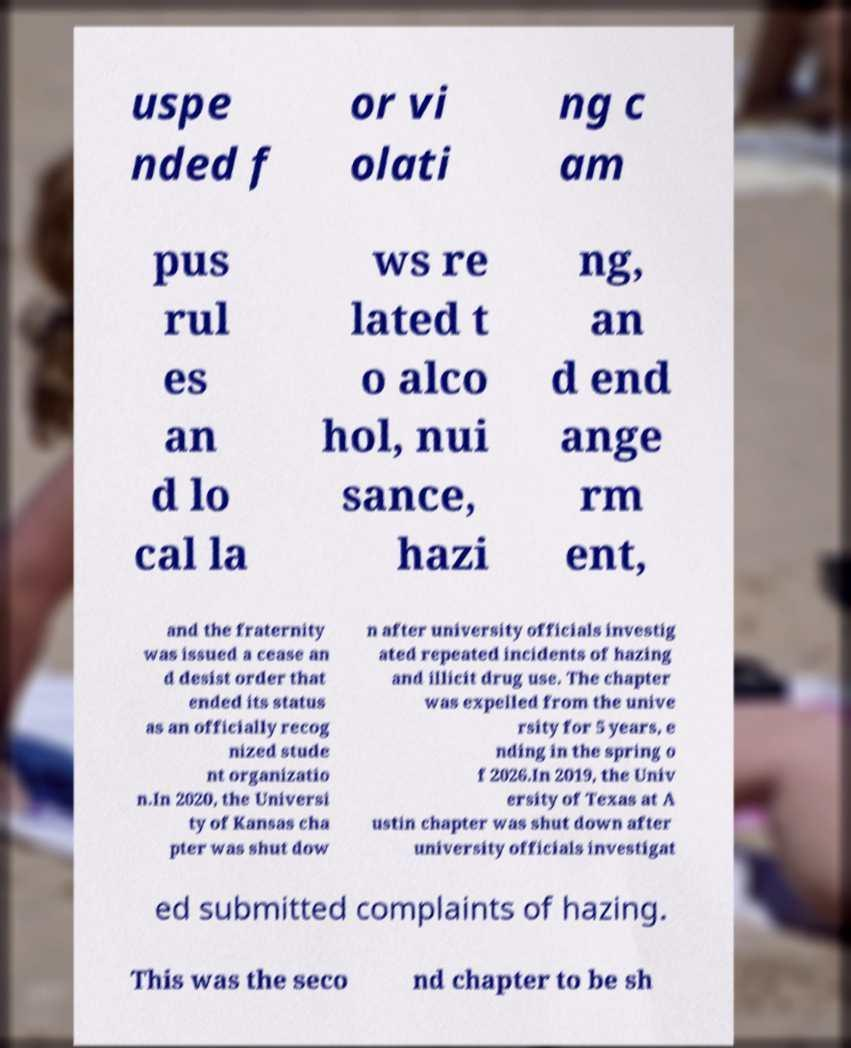I need the written content from this picture converted into text. Can you do that? uspe nded f or vi olati ng c am pus rul es an d lo cal la ws re lated t o alco hol, nui sance, hazi ng, an d end ange rm ent, and the fraternity was issued a cease an d desist order that ended its status as an officially recog nized stude nt organizatio n.In 2020, the Universi ty of Kansas cha pter was shut dow n after university officials investig ated repeated incidents of hazing and illicit drug use. The chapter was expelled from the unive rsity for 5 years, e nding in the spring o f 2026.In 2019, the Univ ersity of Texas at A ustin chapter was shut down after university officials investigat ed submitted complaints of hazing. This was the seco nd chapter to be sh 